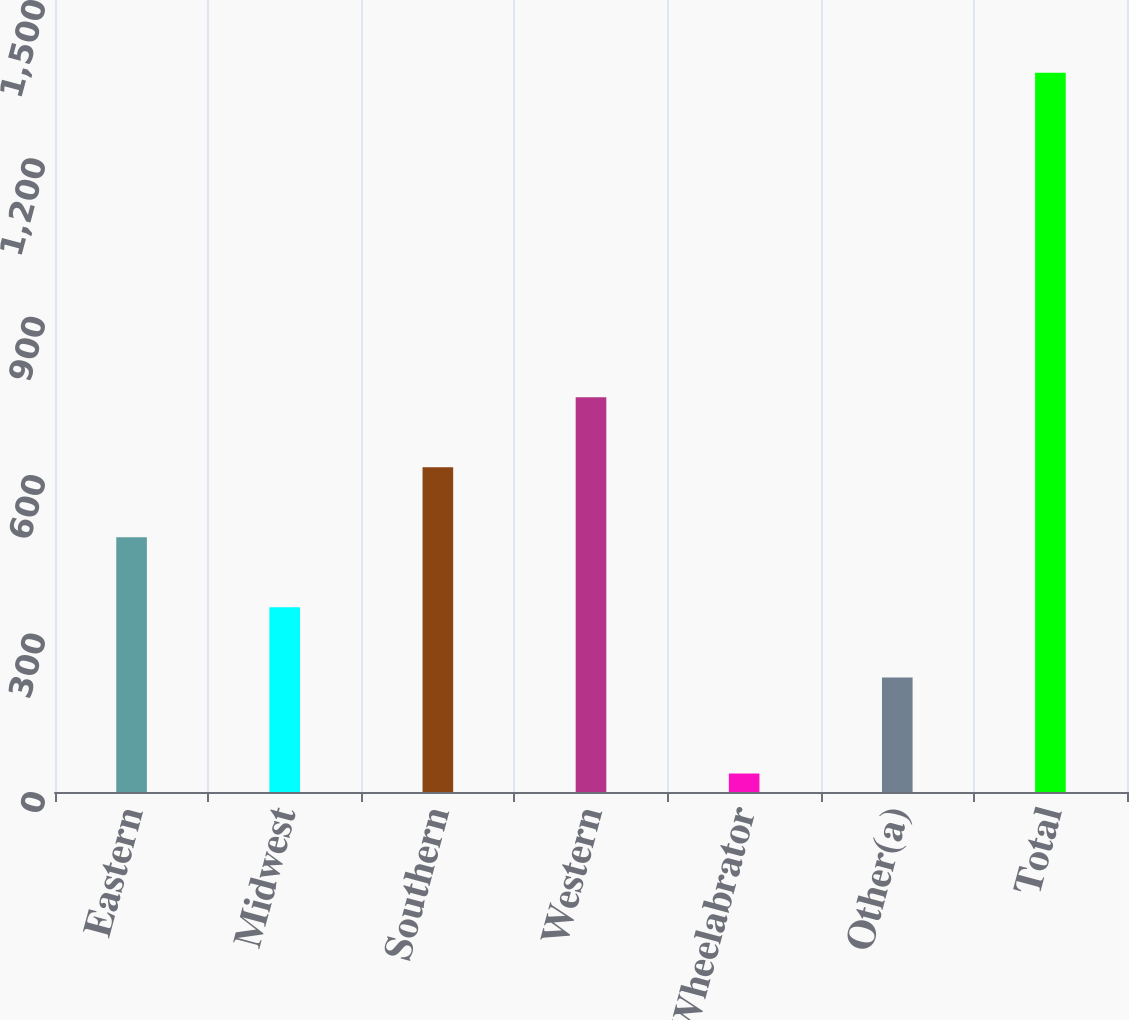<chart> <loc_0><loc_0><loc_500><loc_500><bar_chart><fcel>Eastern<fcel>Midwest<fcel>Southern<fcel>Western<fcel>Wheelabrator<fcel>Other(a)<fcel>Total<nl><fcel>482.4<fcel>349.7<fcel>615.1<fcel>747.8<fcel>35<fcel>217<fcel>1362<nl></chart> 